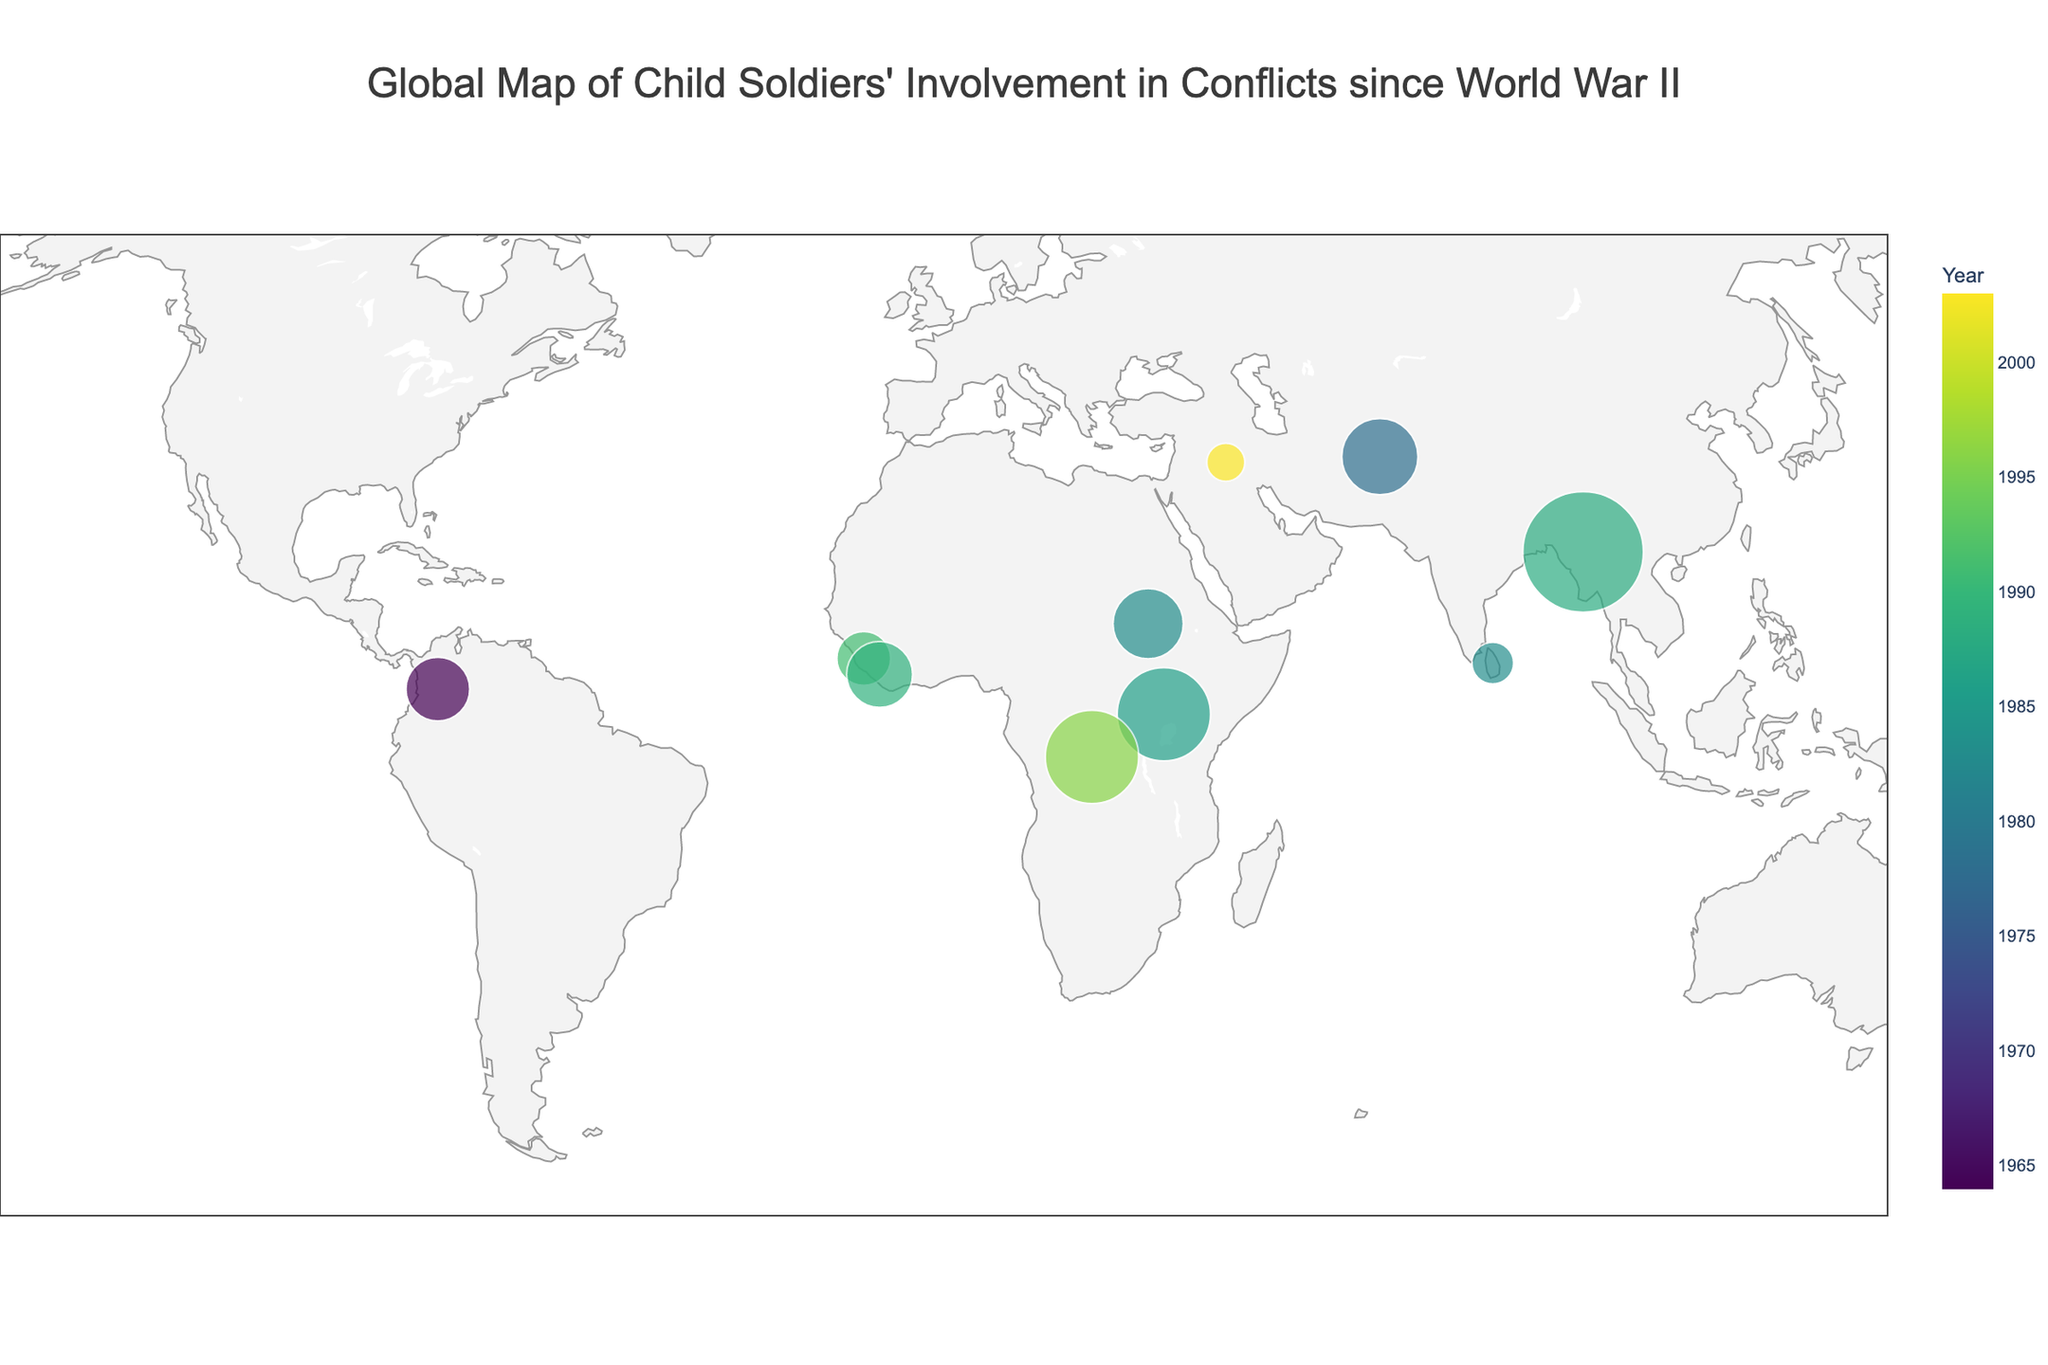How many estimated child soldiers were involved in the Second Congo War? Look at the annotation or the hover information over the Democratic Republic of Congo point. It states that there were 30,000 estimated child soldiers involved.
Answer: 30,000 Which country had the earliest reported use of child soldiers among the listed conflicts? Check the hover information or the color legend to find the earliest year. Afghanistan has the year 1978 for the Soviet-Afghan War.
Answer: Afghanistan What is the total estimated number of child soldiers for the conflicts in Africa listed on the map? Identify and sum the estimated child soldiers for African countries: Sierra Leone (10,000), Uganda (30,000), Democratic Republic of Congo (30,000), Sudan (17,000), Liberia (15,000). The total is 10,000 + 30,000 + 30,000 + 17,000 + 15,000 = 102,000.
Answer: 102,000 Which conflict had the highest reported number of child soldiers? Refer to the hover information for each point to find the highest number; Myanmar's internal conflict has the highest with 50,000 child soldiers.
Answer: Internal conflict in Myanmar Are there more estimated child soldiers in Sri Lanka or Afghanistan? Compare the numbers by checking the hover information: Sri Lanka (6,000) vs. Afghanistan (20,000). Afghanistan has more.
Answer: Afghanistan What is the average number of estimated child soldiers for the conflicts listed on the map? Sum up all reported child soldiers: 10,000 (Sierra Leone) + 30,000 (Uganda) + 50,000 (Myanmar) + 30,000 (Dem. Rep. of Congo) + 20,000 (Afghanistan) + 14,000 (Colombia) + 17,000 (Sudan) + 15,000 (Liberia) + 6,000 (Sri Lanka) + 5,000 (Iraq) = 197,000. Divide this by the number of data points, 10: 197,000 / 10 = 19,700.
Answer: 19,700 Which region (continent) appears to have the most colored points indicating child soldiers' involvement in conflicts? Visually observe the map to count the number of points per continent. Africa has 5 points, more than any other region.
Answer: Africa What is the range of years during which the reported conflicts involving child soldiers occurred? Look at the color legend for the earliest and latest years: The earliest year is 1978 (Afghanistan), and the latest is 2003 (Iraq War). The range is 1978 to 2003.
Answer: 25 years Which country in South America is reported to have child soldiers' involvement, and how many are there? Check the hover information for the point located in South America: Colombia, with 14,000 estimated child soldiers.
Answer: Colombia, 14,000 